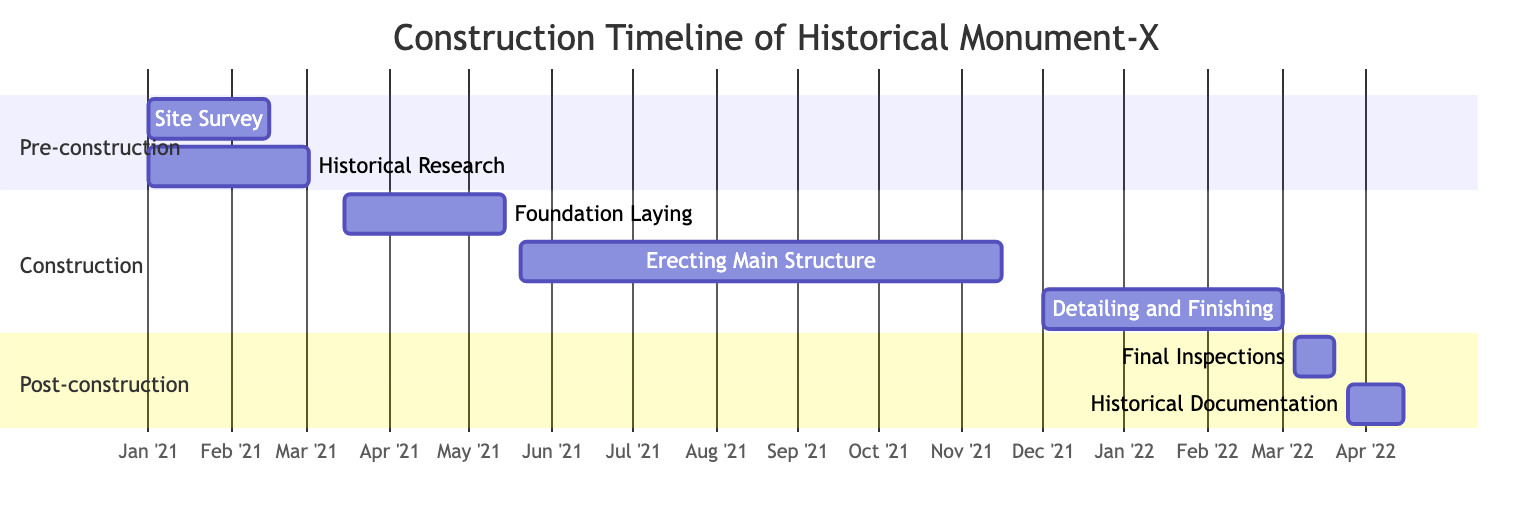What's the duration of the "Erecting Main Structure" task? The diagram indicates that the "Erecting Main Structure" task spans from May 20, 2021, to November 20, 2021, which is a total of 180 days as specified in the diagram.
Answer: 180 days What task follows "Foundation Laying"? The "Foundation Laying" task ends on May 15, 2021. The next task in the diagram, starting shortly after, is "Erecting Main Structure," which begins on May 20, 2021.
Answer: Erecting Main Structure How many tasks are in the "Construction" phase? The "Construction" phase features three tasks: "Foundation Laying," "Erecting Main Structure," and "Detailing and Finishing." Counting these mentioned tasks reveals a total of three tasks.
Answer: 3 What is the start date of "Historical Documentation"? In the diagram, the "Historical Documentation" task is marked with a start date of March 25, 2022. This specific date can be directly taken from the indicated information.
Answer: March 25, 2022 Which task has the longest duration between "Site Survey" and "Detailing and Finishing"? The "Site Survey" has a duration of 45 days, while "Detailing and Finishing" lasts for 90 days. Since 90 days is longer than 45, "Detailing and Finishing" has the longer duration.
Answer: Detailing and Finishing What is the end date of the "Final Inspections"? The "Final Inspections" task is noted in the diagram to end on March 20, 2022. This date can be read directly from the diagram for that task.
Answer: March 20, 2022 Which section has the earliest start date for any task? The "Pre-construction" section starts with the task "Site Survey" on January 1, 2021, which is earlier than any task in the other sections. Hence, this has the earliest start date.
Answer: Pre-construction What task comes last in the overall timeline? Among all the tasks listed, "Historical Documentation" concludes the timeline, as it starts after "Final Inspections" and lasts until April 15, 2022. Thus, it is the last task in the entire timeline.
Answer: Historical Documentation 